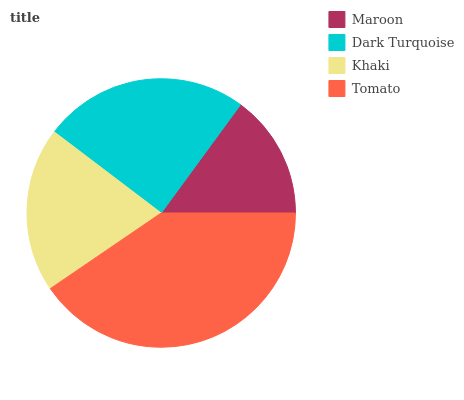Is Maroon the minimum?
Answer yes or no. Yes. Is Tomato the maximum?
Answer yes or no. Yes. Is Dark Turquoise the minimum?
Answer yes or no. No. Is Dark Turquoise the maximum?
Answer yes or no. No. Is Dark Turquoise greater than Maroon?
Answer yes or no. Yes. Is Maroon less than Dark Turquoise?
Answer yes or no. Yes. Is Maroon greater than Dark Turquoise?
Answer yes or no. No. Is Dark Turquoise less than Maroon?
Answer yes or no. No. Is Dark Turquoise the high median?
Answer yes or no. Yes. Is Khaki the low median?
Answer yes or no. Yes. Is Khaki the high median?
Answer yes or no. No. Is Dark Turquoise the low median?
Answer yes or no. No. 